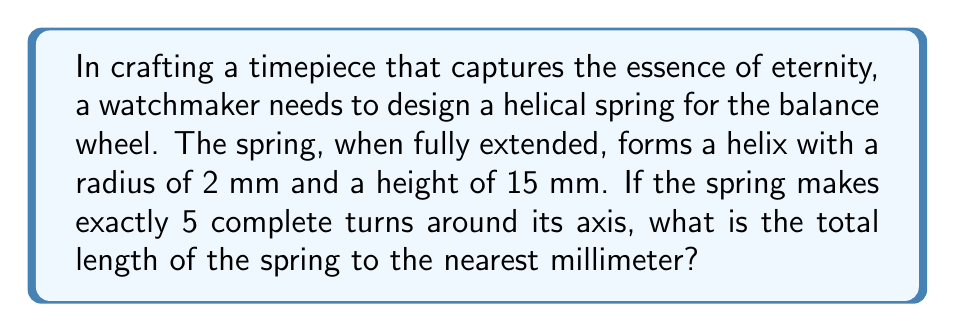Solve this math problem. To solve this problem, we need to understand that a helical spring, when extended, forms a helix. The length of a helix can be calculated using the formula:

$$L = \sqrt{(2\pi rn)^2 + h^2}$$

Where:
$L$ = length of the helix
$r$ = radius of the helix
$n$ = number of complete turns
$h$ = height of the helix

Given:
$r = 2$ mm
$n = 5$ turns
$h = 15$ mm

Let's substitute these values into our formula:

$$L = \sqrt{(2\pi \cdot 2 \cdot 5)^2 + 15^2}$$

Simplify inside the parentheses:
$$L = \sqrt{(20\pi)^2 + 15^2}$$

Calculate $20\pi$:
$$L = \sqrt{(62.8318...)^2 + 15^2}$$

Square the terms:
$$L = \sqrt{3947.8417... + 225}$$

Add the terms under the square root:
$$L = \sqrt{4172.8417...}$$

Take the square root:
$$L = 64.5975... \text{ mm}$$

Rounding to the nearest millimeter:
$$L \approx 65 \text{ mm}$$
Answer: $65 \text{ mm}$ 